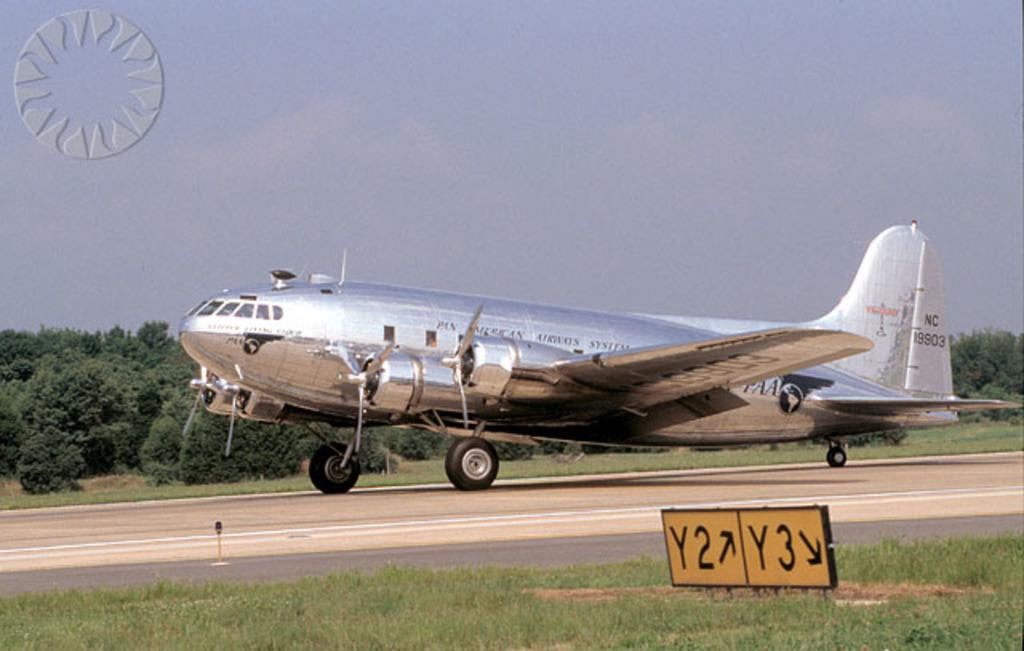<image>
Write a terse but informative summary of the picture. a silver plane with American Airways on it 